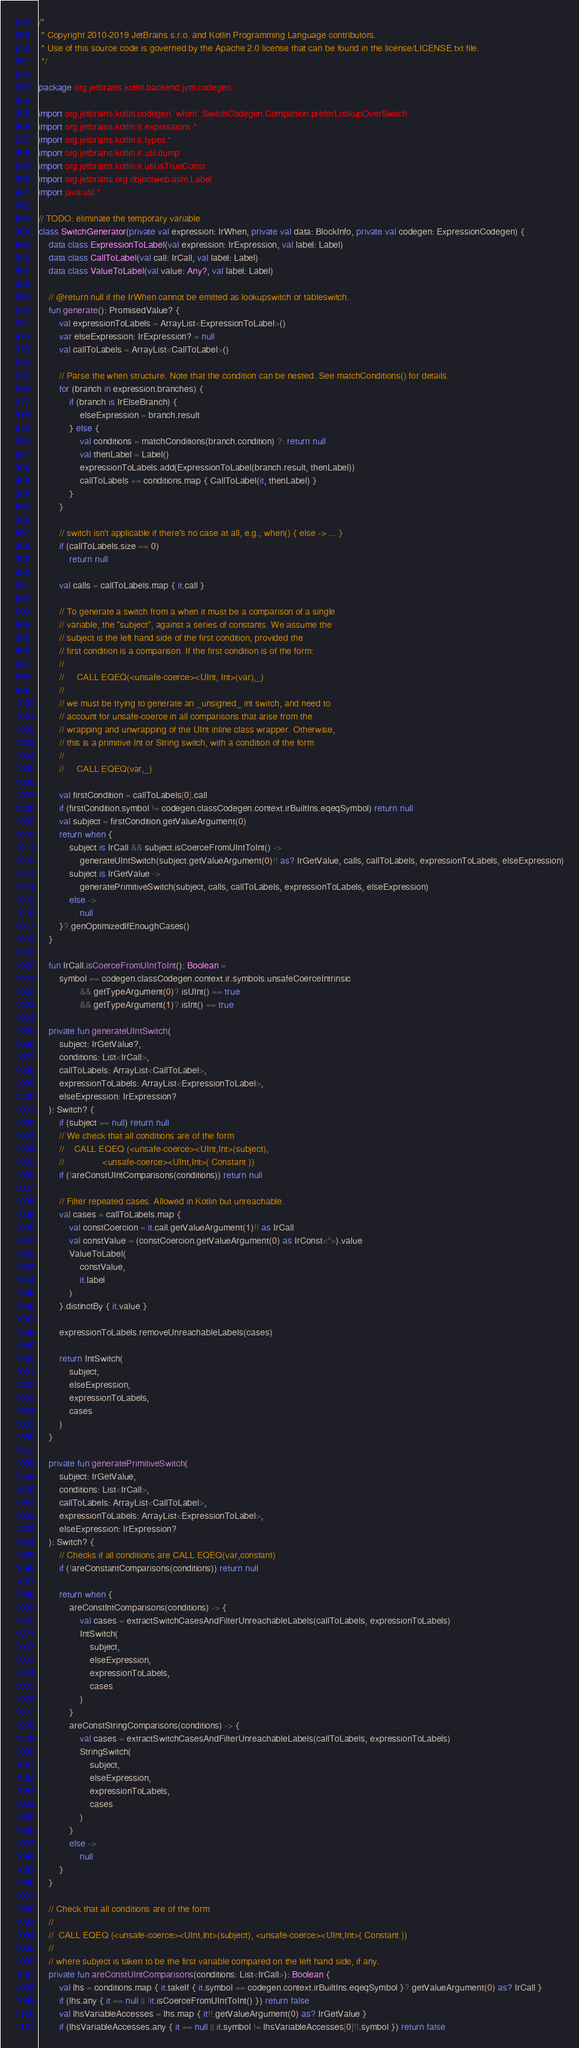<code> <loc_0><loc_0><loc_500><loc_500><_Kotlin_>/*
 * Copyright 2010-2019 JetBrains s.r.o. and Kotlin Programming Language contributors.
 * Use of this source code is governed by the Apache 2.0 license that can be found in the license/LICENSE.txt file.
 */

package org.jetbrains.kotlin.backend.jvm.codegen

import org.jetbrains.kotlin.codegen.`when`.SwitchCodegen.Companion.preferLookupOverSwitch
import org.jetbrains.kotlin.ir.expressions.*
import org.jetbrains.kotlin.ir.types.*
import org.jetbrains.kotlin.ir.util.dump
import org.jetbrains.kotlin.ir.util.isTrueConst
import org.jetbrains.org.objectweb.asm.Label
import java.util.*

// TODO: eliminate the temporary variable
class SwitchGenerator(private val expression: IrWhen, private val data: BlockInfo, private val codegen: ExpressionCodegen) {
    data class ExpressionToLabel(val expression: IrExpression, val label: Label)
    data class CallToLabel(val call: IrCall, val label: Label)
    data class ValueToLabel(val value: Any?, val label: Label)

    // @return null if the IrWhen cannot be emitted as lookupswitch or tableswitch.
    fun generate(): PromisedValue? {
        val expressionToLabels = ArrayList<ExpressionToLabel>()
        var elseExpression: IrExpression? = null
        val callToLabels = ArrayList<CallToLabel>()

        // Parse the when structure. Note that the condition can be nested. See matchConditions() for details.
        for (branch in expression.branches) {
            if (branch is IrElseBranch) {
                elseExpression = branch.result
            } else {
                val conditions = matchConditions(branch.condition) ?: return null
                val thenLabel = Label()
                expressionToLabels.add(ExpressionToLabel(branch.result, thenLabel))
                callToLabels += conditions.map { CallToLabel(it, thenLabel) }
            }
        }

        // switch isn't applicable if there's no case at all, e.g., when() { else -> ... }
        if (callToLabels.size == 0)
            return null

        val calls = callToLabels.map { it.call }

        // To generate a switch from a when it must be a comparison of a single
        // variable, the "subject", against a series of constants. We assume the
        // subject is the left hand side of the first condition, provided the
        // first condition is a comparison. If the first condition is of the form:
        //
        //     CALL EQEQ(<unsafe-coerce><UInt, Int>(var),_)
        //
        // we must be trying to generate an _unsigned_ int switch, and need to
        // account for unsafe-coerce in all comparisons that arise from the
        // wrapping and unwrapping of the UInt inline class wrapper. Otherwise,
        // this is a primitive Int or String switch, with a condition of the form
        //
        //     CALL EQEQ(var,_)

        val firstCondition = callToLabels[0].call
        if (firstCondition.symbol != codegen.classCodegen.context.irBuiltIns.eqeqSymbol) return null
        val subject = firstCondition.getValueArgument(0)
        return when {
            subject is IrCall && subject.isCoerceFromUIntToInt() ->
                generateUIntSwitch(subject.getValueArgument(0)!! as? IrGetValue, calls, callToLabels, expressionToLabels, elseExpression)
            subject is IrGetValue ->
                generatePrimitiveSwitch(subject, calls, callToLabels, expressionToLabels, elseExpression)
            else ->
                null
        }?.genOptimizedIfEnoughCases()
    }

    fun IrCall.isCoerceFromUIntToInt(): Boolean =
        symbol == codegen.classCodegen.context.ir.symbols.unsafeCoerceIntrinsic
                && getTypeArgument(0)?.isUInt() == true
                && getTypeArgument(1)?.isInt() == true

    private fun generateUIntSwitch(
        subject: IrGetValue?,
        conditions: List<IrCall>,
        callToLabels: ArrayList<CallToLabel>,
        expressionToLabels: ArrayList<ExpressionToLabel>,
        elseExpression: IrExpression?
    ): Switch? {
        if (subject == null) return null
        // We check that all conditions are of the form
        //    CALL EQEQ (<unsafe-coerce><UInt,Int>(subject),
        //               <unsafe-coerce><UInt,Int>( Constant ))
        if (!areConstUIntComparisons(conditions)) return null

        // Filter repeated cases. Allowed in Kotlin but unreachable.
        val cases = callToLabels.map {
            val constCoercion = it.call.getValueArgument(1)!! as IrCall
            val constValue = (constCoercion.getValueArgument(0) as IrConst<*>).value
            ValueToLabel(
                constValue,
                it.label
            )
        }.distinctBy { it.value }

        expressionToLabels.removeUnreachableLabels(cases)

        return IntSwitch(
            subject,
            elseExpression,
            expressionToLabels,
            cases
        )
    }

    private fun generatePrimitiveSwitch(
        subject: IrGetValue,
        conditions: List<IrCall>,
        callToLabels: ArrayList<CallToLabel>,
        expressionToLabels: ArrayList<ExpressionToLabel>,
        elseExpression: IrExpression?
    ): Switch? {
        // Checks if all conditions are CALL EQEQ(var,constant)
        if (!areConstantComparisons(conditions)) return null

        return when {
            areConstIntComparisons(conditions) -> {
                val cases = extractSwitchCasesAndFilterUnreachableLabels(callToLabels, expressionToLabels)
                IntSwitch(
                    subject,
                    elseExpression,
                    expressionToLabels,
                    cases
                )
            }
            areConstStringComparisons(conditions) -> {
                val cases = extractSwitchCasesAndFilterUnreachableLabels(callToLabels, expressionToLabels)
                StringSwitch(
                    subject,
                    elseExpression,
                    expressionToLabels,
                    cases
                )
            }
            else ->
                null
        }
    }

    // Check that all conditions are of the form
    //
    //  CALL EQEQ (<unsafe-coerce><UInt,Int>(subject), <unsafe-coerce><UInt,Int>( Constant ))
    //
    // where subject is taken to be the first variable compared on the left hand side, if any.
    private fun areConstUIntComparisons(conditions: List<IrCall>): Boolean {
        val lhs = conditions.map { it.takeIf { it.symbol == codegen.context.irBuiltIns.eqeqSymbol }?.getValueArgument(0) as? IrCall }
        if (lhs.any { it == null || !it.isCoerceFromUIntToInt() }) return false
        val lhsVariableAccesses = lhs.map { it!!.getValueArgument(0) as? IrGetValue }
        if (lhsVariableAccesses.any { it == null || it.symbol != lhsVariableAccesses[0]!!.symbol }) return false
</code> 